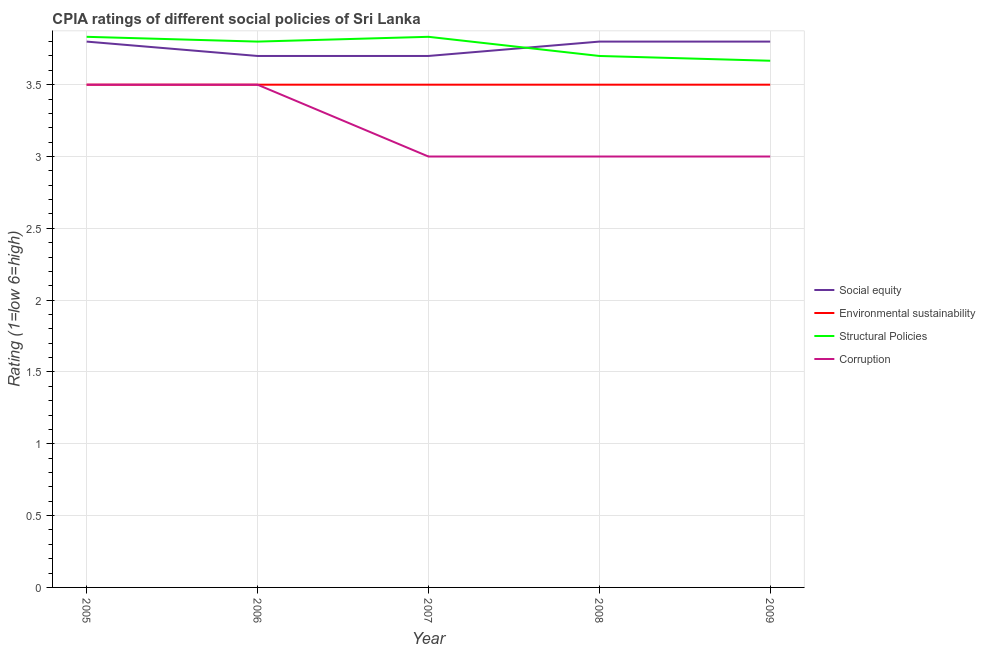What is the cpia rating of structural policies in 2005?
Give a very brief answer. 3.83. Across all years, what is the minimum cpia rating of environmental sustainability?
Provide a short and direct response. 3.5. In which year was the cpia rating of environmental sustainability maximum?
Keep it short and to the point. 2005. What is the difference between the cpia rating of environmental sustainability in 2006 and that in 2007?
Offer a terse response. 0. What is the difference between the cpia rating of structural policies in 2009 and the cpia rating of corruption in 2006?
Provide a succinct answer. 0.17. What is the average cpia rating of social equity per year?
Make the answer very short. 3.76. In the year 2008, what is the difference between the cpia rating of corruption and cpia rating of environmental sustainability?
Offer a terse response. -0.5. Is the cpia rating of structural policies in 2007 less than that in 2008?
Keep it short and to the point. No. What is the difference between the highest and the second highest cpia rating of environmental sustainability?
Provide a short and direct response. 0. In how many years, is the cpia rating of structural policies greater than the average cpia rating of structural policies taken over all years?
Give a very brief answer. 3. Is the sum of the cpia rating of social equity in 2006 and 2009 greater than the maximum cpia rating of environmental sustainability across all years?
Provide a succinct answer. Yes. Does the cpia rating of corruption monotonically increase over the years?
Keep it short and to the point. No. How many years are there in the graph?
Ensure brevity in your answer.  5. Are the values on the major ticks of Y-axis written in scientific E-notation?
Ensure brevity in your answer.  No. Does the graph contain grids?
Offer a terse response. Yes. How many legend labels are there?
Your response must be concise. 4. How are the legend labels stacked?
Provide a short and direct response. Vertical. What is the title of the graph?
Provide a succinct answer. CPIA ratings of different social policies of Sri Lanka. Does "Primary education" appear as one of the legend labels in the graph?
Offer a terse response. No. What is the label or title of the X-axis?
Offer a terse response. Year. What is the Rating (1=low 6=high) in Social equity in 2005?
Provide a short and direct response. 3.8. What is the Rating (1=low 6=high) of Environmental sustainability in 2005?
Make the answer very short. 3.5. What is the Rating (1=low 6=high) in Structural Policies in 2005?
Provide a short and direct response. 3.83. What is the Rating (1=low 6=high) of Corruption in 2005?
Keep it short and to the point. 3.5. What is the Rating (1=low 6=high) in Environmental sustainability in 2006?
Your response must be concise. 3.5. What is the Rating (1=low 6=high) in Corruption in 2006?
Ensure brevity in your answer.  3.5. What is the Rating (1=low 6=high) of Environmental sustainability in 2007?
Your response must be concise. 3.5. What is the Rating (1=low 6=high) of Structural Policies in 2007?
Offer a very short reply. 3.83. What is the Rating (1=low 6=high) in Social equity in 2008?
Your answer should be compact. 3.8. What is the Rating (1=low 6=high) of Environmental sustainability in 2009?
Your answer should be compact. 3.5. What is the Rating (1=low 6=high) in Structural Policies in 2009?
Keep it short and to the point. 3.67. Across all years, what is the maximum Rating (1=low 6=high) of Social equity?
Your response must be concise. 3.8. Across all years, what is the maximum Rating (1=low 6=high) in Structural Policies?
Your answer should be compact. 3.83. Across all years, what is the maximum Rating (1=low 6=high) of Corruption?
Your answer should be compact. 3.5. Across all years, what is the minimum Rating (1=low 6=high) of Social equity?
Provide a short and direct response. 3.7. Across all years, what is the minimum Rating (1=low 6=high) of Structural Policies?
Offer a terse response. 3.67. What is the total Rating (1=low 6=high) of Social equity in the graph?
Make the answer very short. 18.8. What is the total Rating (1=low 6=high) in Environmental sustainability in the graph?
Make the answer very short. 17.5. What is the total Rating (1=low 6=high) of Structural Policies in the graph?
Your answer should be very brief. 18.83. What is the difference between the Rating (1=low 6=high) of Environmental sustainability in 2005 and that in 2006?
Offer a terse response. 0. What is the difference between the Rating (1=low 6=high) in Social equity in 2005 and that in 2007?
Your answer should be very brief. 0.1. What is the difference between the Rating (1=low 6=high) of Corruption in 2005 and that in 2007?
Ensure brevity in your answer.  0.5. What is the difference between the Rating (1=low 6=high) of Environmental sustainability in 2005 and that in 2008?
Your response must be concise. 0. What is the difference between the Rating (1=low 6=high) of Structural Policies in 2005 and that in 2008?
Offer a terse response. 0.13. What is the difference between the Rating (1=low 6=high) in Social equity in 2005 and that in 2009?
Provide a short and direct response. 0. What is the difference between the Rating (1=low 6=high) of Environmental sustainability in 2005 and that in 2009?
Offer a very short reply. 0. What is the difference between the Rating (1=low 6=high) of Social equity in 2006 and that in 2007?
Make the answer very short. 0. What is the difference between the Rating (1=low 6=high) in Environmental sustainability in 2006 and that in 2007?
Provide a succinct answer. 0. What is the difference between the Rating (1=low 6=high) of Structural Policies in 2006 and that in 2007?
Give a very brief answer. -0.03. What is the difference between the Rating (1=low 6=high) in Corruption in 2006 and that in 2007?
Keep it short and to the point. 0.5. What is the difference between the Rating (1=low 6=high) in Social equity in 2006 and that in 2008?
Your response must be concise. -0.1. What is the difference between the Rating (1=low 6=high) of Structural Policies in 2006 and that in 2008?
Provide a succinct answer. 0.1. What is the difference between the Rating (1=low 6=high) of Structural Policies in 2006 and that in 2009?
Give a very brief answer. 0.13. What is the difference between the Rating (1=low 6=high) of Corruption in 2006 and that in 2009?
Make the answer very short. 0.5. What is the difference between the Rating (1=low 6=high) in Social equity in 2007 and that in 2008?
Make the answer very short. -0.1. What is the difference between the Rating (1=low 6=high) of Structural Policies in 2007 and that in 2008?
Offer a terse response. 0.13. What is the difference between the Rating (1=low 6=high) in Social equity in 2007 and that in 2009?
Your response must be concise. -0.1. What is the difference between the Rating (1=low 6=high) of Structural Policies in 2007 and that in 2009?
Your response must be concise. 0.17. What is the difference between the Rating (1=low 6=high) of Corruption in 2007 and that in 2009?
Provide a short and direct response. 0. What is the difference between the Rating (1=low 6=high) in Structural Policies in 2008 and that in 2009?
Keep it short and to the point. 0.03. What is the difference between the Rating (1=low 6=high) in Social equity in 2005 and the Rating (1=low 6=high) in Environmental sustainability in 2006?
Your answer should be compact. 0.3. What is the difference between the Rating (1=low 6=high) of Social equity in 2005 and the Rating (1=low 6=high) of Structural Policies in 2006?
Your answer should be compact. 0. What is the difference between the Rating (1=low 6=high) of Environmental sustainability in 2005 and the Rating (1=low 6=high) of Corruption in 2006?
Your response must be concise. 0. What is the difference between the Rating (1=low 6=high) of Social equity in 2005 and the Rating (1=low 6=high) of Environmental sustainability in 2007?
Make the answer very short. 0.3. What is the difference between the Rating (1=low 6=high) of Social equity in 2005 and the Rating (1=low 6=high) of Structural Policies in 2007?
Keep it short and to the point. -0.03. What is the difference between the Rating (1=low 6=high) in Social equity in 2005 and the Rating (1=low 6=high) in Corruption in 2007?
Ensure brevity in your answer.  0.8. What is the difference between the Rating (1=low 6=high) in Structural Policies in 2005 and the Rating (1=low 6=high) in Corruption in 2007?
Your response must be concise. 0.83. What is the difference between the Rating (1=low 6=high) of Social equity in 2005 and the Rating (1=low 6=high) of Environmental sustainability in 2008?
Provide a short and direct response. 0.3. What is the difference between the Rating (1=low 6=high) in Social equity in 2005 and the Rating (1=low 6=high) in Structural Policies in 2008?
Give a very brief answer. 0.1. What is the difference between the Rating (1=low 6=high) of Social equity in 2005 and the Rating (1=low 6=high) of Corruption in 2008?
Make the answer very short. 0.8. What is the difference between the Rating (1=low 6=high) in Environmental sustainability in 2005 and the Rating (1=low 6=high) in Corruption in 2008?
Keep it short and to the point. 0.5. What is the difference between the Rating (1=low 6=high) of Structural Policies in 2005 and the Rating (1=low 6=high) of Corruption in 2008?
Your response must be concise. 0.83. What is the difference between the Rating (1=low 6=high) of Social equity in 2005 and the Rating (1=low 6=high) of Environmental sustainability in 2009?
Your answer should be compact. 0.3. What is the difference between the Rating (1=low 6=high) in Social equity in 2005 and the Rating (1=low 6=high) in Structural Policies in 2009?
Provide a succinct answer. 0.13. What is the difference between the Rating (1=low 6=high) in Social equity in 2006 and the Rating (1=low 6=high) in Structural Policies in 2007?
Provide a succinct answer. -0.13. What is the difference between the Rating (1=low 6=high) of Social equity in 2006 and the Rating (1=low 6=high) of Corruption in 2007?
Provide a short and direct response. 0.7. What is the difference between the Rating (1=low 6=high) of Environmental sustainability in 2006 and the Rating (1=low 6=high) of Corruption in 2007?
Offer a very short reply. 0.5. What is the difference between the Rating (1=low 6=high) in Structural Policies in 2006 and the Rating (1=low 6=high) in Corruption in 2007?
Provide a succinct answer. 0.8. What is the difference between the Rating (1=low 6=high) in Social equity in 2006 and the Rating (1=low 6=high) in Environmental sustainability in 2009?
Keep it short and to the point. 0.2. What is the difference between the Rating (1=low 6=high) in Social equity in 2006 and the Rating (1=low 6=high) in Structural Policies in 2009?
Make the answer very short. 0.03. What is the difference between the Rating (1=low 6=high) of Environmental sustainability in 2006 and the Rating (1=low 6=high) of Structural Policies in 2009?
Offer a very short reply. -0.17. What is the difference between the Rating (1=low 6=high) in Environmental sustainability in 2006 and the Rating (1=low 6=high) in Corruption in 2009?
Offer a very short reply. 0.5. What is the difference between the Rating (1=low 6=high) of Social equity in 2007 and the Rating (1=low 6=high) of Environmental sustainability in 2008?
Your answer should be very brief. 0.2. What is the difference between the Rating (1=low 6=high) of Environmental sustainability in 2007 and the Rating (1=low 6=high) of Structural Policies in 2008?
Your answer should be compact. -0.2. What is the difference between the Rating (1=low 6=high) of Structural Policies in 2007 and the Rating (1=low 6=high) of Corruption in 2008?
Ensure brevity in your answer.  0.83. What is the difference between the Rating (1=low 6=high) of Social equity in 2007 and the Rating (1=low 6=high) of Environmental sustainability in 2009?
Provide a succinct answer. 0.2. What is the difference between the Rating (1=low 6=high) in Social equity in 2007 and the Rating (1=low 6=high) in Corruption in 2009?
Ensure brevity in your answer.  0.7. What is the difference between the Rating (1=low 6=high) of Environmental sustainability in 2007 and the Rating (1=low 6=high) of Corruption in 2009?
Provide a succinct answer. 0.5. What is the difference between the Rating (1=low 6=high) of Structural Policies in 2007 and the Rating (1=low 6=high) of Corruption in 2009?
Your response must be concise. 0.83. What is the difference between the Rating (1=low 6=high) of Social equity in 2008 and the Rating (1=low 6=high) of Structural Policies in 2009?
Provide a short and direct response. 0.13. What is the difference between the Rating (1=low 6=high) of Environmental sustainability in 2008 and the Rating (1=low 6=high) of Structural Policies in 2009?
Offer a very short reply. -0.17. What is the difference between the Rating (1=low 6=high) in Environmental sustainability in 2008 and the Rating (1=low 6=high) in Corruption in 2009?
Give a very brief answer. 0.5. What is the difference between the Rating (1=low 6=high) in Structural Policies in 2008 and the Rating (1=low 6=high) in Corruption in 2009?
Keep it short and to the point. 0.7. What is the average Rating (1=low 6=high) of Social equity per year?
Make the answer very short. 3.76. What is the average Rating (1=low 6=high) in Environmental sustainability per year?
Your response must be concise. 3.5. What is the average Rating (1=low 6=high) of Structural Policies per year?
Make the answer very short. 3.77. In the year 2005, what is the difference between the Rating (1=low 6=high) in Social equity and Rating (1=low 6=high) in Environmental sustainability?
Offer a very short reply. 0.3. In the year 2005, what is the difference between the Rating (1=low 6=high) in Social equity and Rating (1=low 6=high) in Structural Policies?
Ensure brevity in your answer.  -0.03. In the year 2006, what is the difference between the Rating (1=low 6=high) of Social equity and Rating (1=low 6=high) of Environmental sustainability?
Offer a very short reply. 0.2. In the year 2006, what is the difference between the Rating (1=low 6=high) of Social equity and Rating (1=low 6=high) of Structural Policies?
Offer a very short reply. -0.1. In the year 2006, what is the difference between the Rating (1=low 6=high) in Social equity and Rating (1=low 6=high) in Corruption?
Ensure brevity in your answer.  0.2. In the year 2006, what is the difference between the Rating (1=low 6=high) in Environmental sustainability and Rating (1=low 6=high) in Corruption?
Give a very brief answer. 0. In the year 2006, what is the difference between the Rating (1=low 6=high) in Structural Policies and Rating (1=low 6=high) in Corruption?
Ensure brevity in your answer.  0.3. In the year 2007, what is the difference between the Rating (1=low 6=high) in Social equity and Rating (1=low 6=high) in Structural Policies?
Give a very brief answer. -0.13. In the year 2007, what is the difference between the Rating (1=low 6=high) of Social equity and Rating (1=low 6=high) of Corruption?
Ensure brevity in your answer.  0.7. In the year 2007, what is the difference between the Rating (1=low 6=high) in Structural Policies and Rating (1=low 6=high) in Corruption?
Ensure brevity in your answer.  0.83. In the year 2008, what is the difference between the Rating (1=low 6=high) in Social equity and Rating (1=low 6=high) in Structural Policies?
Offer a terse response. 0.1. In the year 2008, what is the difference between the Rating (1=low 6=high) in Social equity and Rating (1=low 6=high) in Corruption?
Give a very brief answer. 0.8. In the year 2008, what is the difference between the Rating (1=low 6=high) in Environmental sustainability and Rating (1=low 6=high) in Corruption?
Give a very brief answer. 0.5. In the year 2009, what is the difference between the Rating (1=low 6=high) of Social equity and Rating (1=low 6=high) of Environmental sustainability?
Ensure brevity in your answer.  0.3. In the year 2009, what is the difference between the Rating (1=low 6=high) of Social equity and Rating (1=low 6=high) of Structural Policies?
Your answer should be very brief. 0.13. In the year 2009, what is the difference between the Rating (1=low 6=high) of Social equity and Rating (1=low 6=high) of Corruption?
Provide a short and direct response. 0.8. In the year 2009, what is the difference between the Rating (1=low 6=high) of Environmental sustainability and Rating (1=low 6=high) of Structural Policies?
Your response must be concise. -0.17. In the year 2009, what is the difference between the Rating (1=low 6=high) in Structural Policies and Rating (1=low 6=high) in Corruption?
Offer a very short reply. 0.67. What is the ratio of the Rating (1=low 6=high) in Social equity in 2005 to that in 2006?
Offer a terse response. 1.03. What is the ratio of the Rating (1=low 6=high) of Structural Policies in 2005 to that in 2006?
Provide a succinct answer. 1.01. What is the ratio of the Rating (1=low 6=high) of Corruption in 2005 to that in 2007?
Provide a short and direct response. 1.17. What is the ratio of the Rating (1=low 6=high) in Social equity in 2005 to that in 2008?
Provide a short and direct response. 1. What is the ratio of the Rating (1=low 6=high) of Environmental sustainability in 2005 to that in 2008?
Ensure brevity in your answer.  1. What is the ratio of the Rating (1=low 6=high) in Structural Policies in 2005 to that in 2008?
Your answer should be very brief. 1.04. What is the ratio of the Rating (1=low 6=high) of Social equity in 2005 to that in 2009?
Offer a terse response. 1. What is the ratio of the Rating (1=low 6=high) in Structural Policies in 2005 to that in 2009?
Your answer should be compact. 1.05. What is the ratio of the Rating (1=low 6=high) of Corruption in 2005 to that in 2009?
Ensure brevity in your answer.  1.17. What is the ratio of the Rating (1=low 6=high) in Social equity in 2006 to that in 2007?
Give a very brief answer. 1. What is the ratio of the Rating (1=low 6=high) of Environmental sustainability in 2006 to that in 2007?
Give a very brief answer. 1. What is the ratio of the Rating (1=low 6=high) in Structural Policies in 2006 to that in 2007?
Provide a short and direct response. 0.99. What is the ratio of the Rating (1=low 6=high) of Corruption in 2006 to that in 2007?
Provide a short and direct response. 1.17. What is the ratio of the Rating (1=low 6=high) of Social equity in 2006 to that in 2008?
Offer a terse response. 0.97. What is the ratio of the Rating (1=low 6=high) in Environmental sustainability in 2006 to that in 2008?
Give a very brief answer. 1. What is the ratio of the Rating (1=low 6=high) of Structural Policies in 2006 to that in 2008?
Give a very brief answer. 1.03. What is the ratio of the Rating (1=low 6=high) of Social equity in 2006 to that in 2009?
Keep it short and to the point. 0.97. What is the ratio of the Rating (1=low 6=high) of Environmental sustainability in 2006 to that in 2009?
Provide a succinct answer. 1. What is the ratio of the Rating (1=low 6=high) in Structural Policies in 2006 to that in 2009?
Provide a succinct answer. 1.04. What is the ratio of the Rating (1=low 6=high) in Corruption in 2006 to that in 2009?
Ensure brevity in your answer.  1.17. What is the ratio of the Rating (1=low 6=high) in Social equity in 2007 to that in 2008?
Make the answer very short. 0.97. What is the ratio of the Rating (1=low 6=high) of Environmental sustainability in 2007 to that in 2008?
Give a very brief answer. 1. What is the ratio of the Rating (1=low 6=high) of Structural Policies in 2007 to that in 2008?
Provide a short and direct response. 1.04. What is the ratio of the Rating (1=low 6=high) of Social equity in 2007 to that in 2009?
Your answer should be compact. 0.97. What is the ratio of the Rating (1=low 6=high) of Environmental sustainability in 2007 to that in 2009?
Your answer should be compact. 1. What is the ratio of the Rating (1=low 6=high) in Structural Policies in 2007 to that in 2009?
Give a very brief answer. 1.05. What is the ratio of the Rating (1=low 6=high) of Corruption in 2007 to that in 2009?
Offer a terse response. 1. What is the ratio of the Rating (1=low 6=high) of Social equity in 2008 to that in 2009?
Give a very brief answer. 1. What is the ratio of the Rating (1=low 6=high) of Structural Policies in 2008 to that in 2009?
Ensure brevity in your answer.  1.01. What is the difference between the highest and the second highest Rating (1=low 6=high) in Structural Policies?
Keep it short and to the point. 0. What is the difference between the highest and the lowest Rating (1=low 6=high) in Structural Policies?
Provide a short and direct response. 0.17. What is the difference between the highest and the lowest Rating (1=low 6=high) of Corruption?
Give a very brief answer. 0.5. 